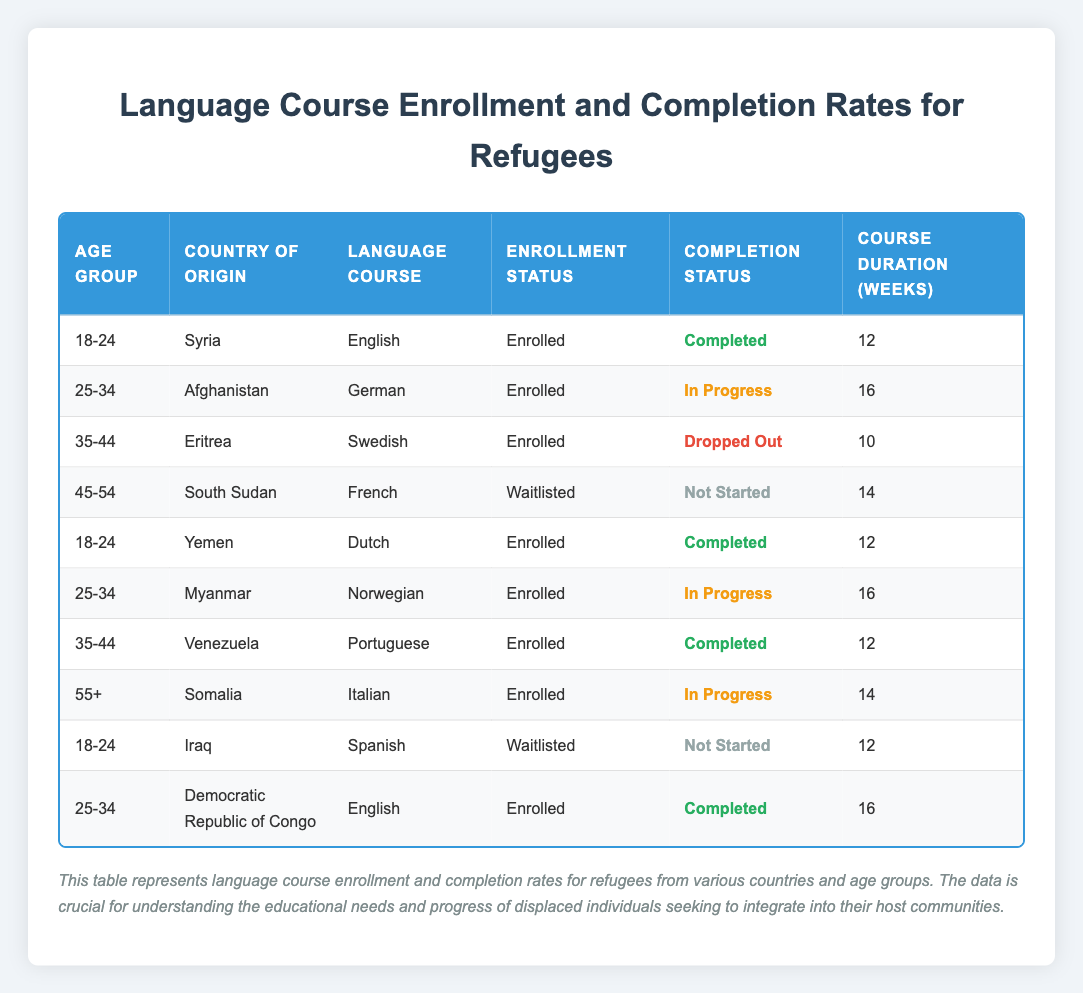What percentage of refugees aged 18-24 have completed their language courses? There are two entries for the age group 18-24. Both entries (from Syria and Yemen) show a completion status of "Completed," making it 100% completion for this age group. The calculation is (2 completed / 2 total) * 100 = 100%.
Answer: 100% How many languages are being taught to refugees from the country of origin Eritrea? The table shows one entry for Eritrea, which is the Swedish language course. Therefore, only one language course is being taught to refugees from Eritrea.
Answer: 1 Is there any refugee in the age group 45-54 who has made progress in their language course? For the age group 45-54, there is one entry from South Sudan, which shows a status of "Waitlisted" and "Not Started," indicating that there is no progress in their language course.
Answer: No What is the average course duration for the completed language courses among refugees? The completed language courses are from refugees aged 18-24 (English and Dutch) and from 25-34 (English). The durations are 12, 12, and 16 weeks respectively. The average is calculated as (12 + 12 + 16) / 3 = 13.33 weeks.
Answer: 13.33 weeks How many refugees are currently enrolled but have not yet started their language courses? There are two entries where the enrollment status is "Waitlisted" and completion status is "Not Started": one from South Sudan and one from Iraq. Thus, there are 2 refugees currently in this situation.
Answer: 2 What is the completion status of the language course for refugees from the country of origin Myanmar? The entry for Myanmar shows an enrollment status of "Enrolled" and a completion status of "In Progress." Thus, the completion status is still currently in progress.
Answer: In Progress Which age group has the highest enrollment in completed language courses? The age group 18-24 has two completed courses (from Syria and Yemen), while the age group 25-34 has one completed course (from the Democratic Republic of Congo). Thus, the group 18-24 has the highest enrollment in completed courses.
Answer: 18-24 Are there any refugees from Somalia who have completed their language courses? The entry for Somalia shows that a refugee in the age group 55+ is enrolled in a language course that is currently "In Progress." There is no record of completion for refugees from Somalia.
Answer: No 